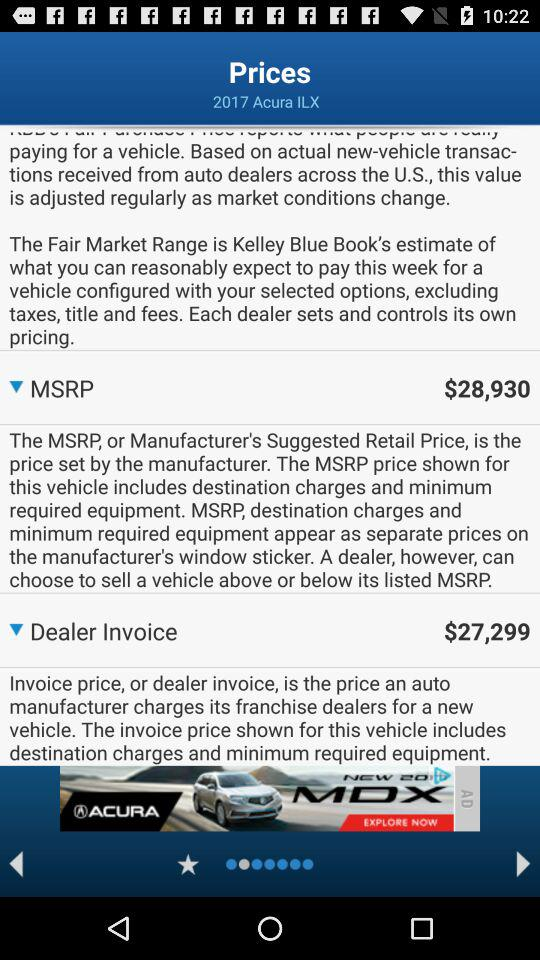How much more is the MSRP than the dealer invoice?
Answer the question using a single word or phrase. $1631 